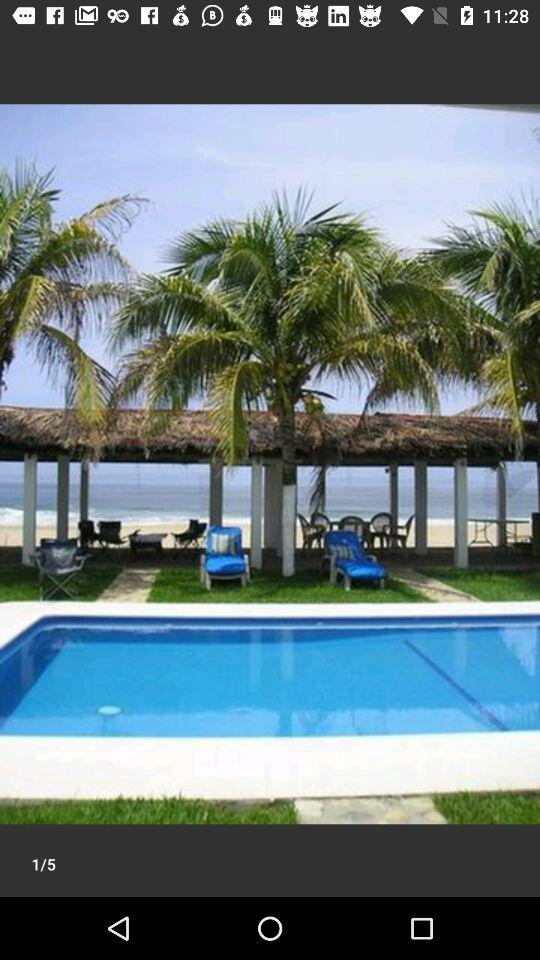How many images in total are there? There are 5 images in total. 